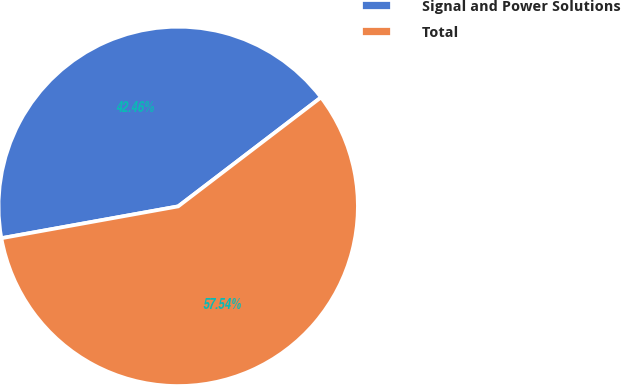<chart> <loc_0><loc_0><loc_500><loc_500><pie_chart><fcel>Signal and Power Solutions<fcel>Total<nl><fcel>42.46%<fcel>57.54%<nl></chart> 